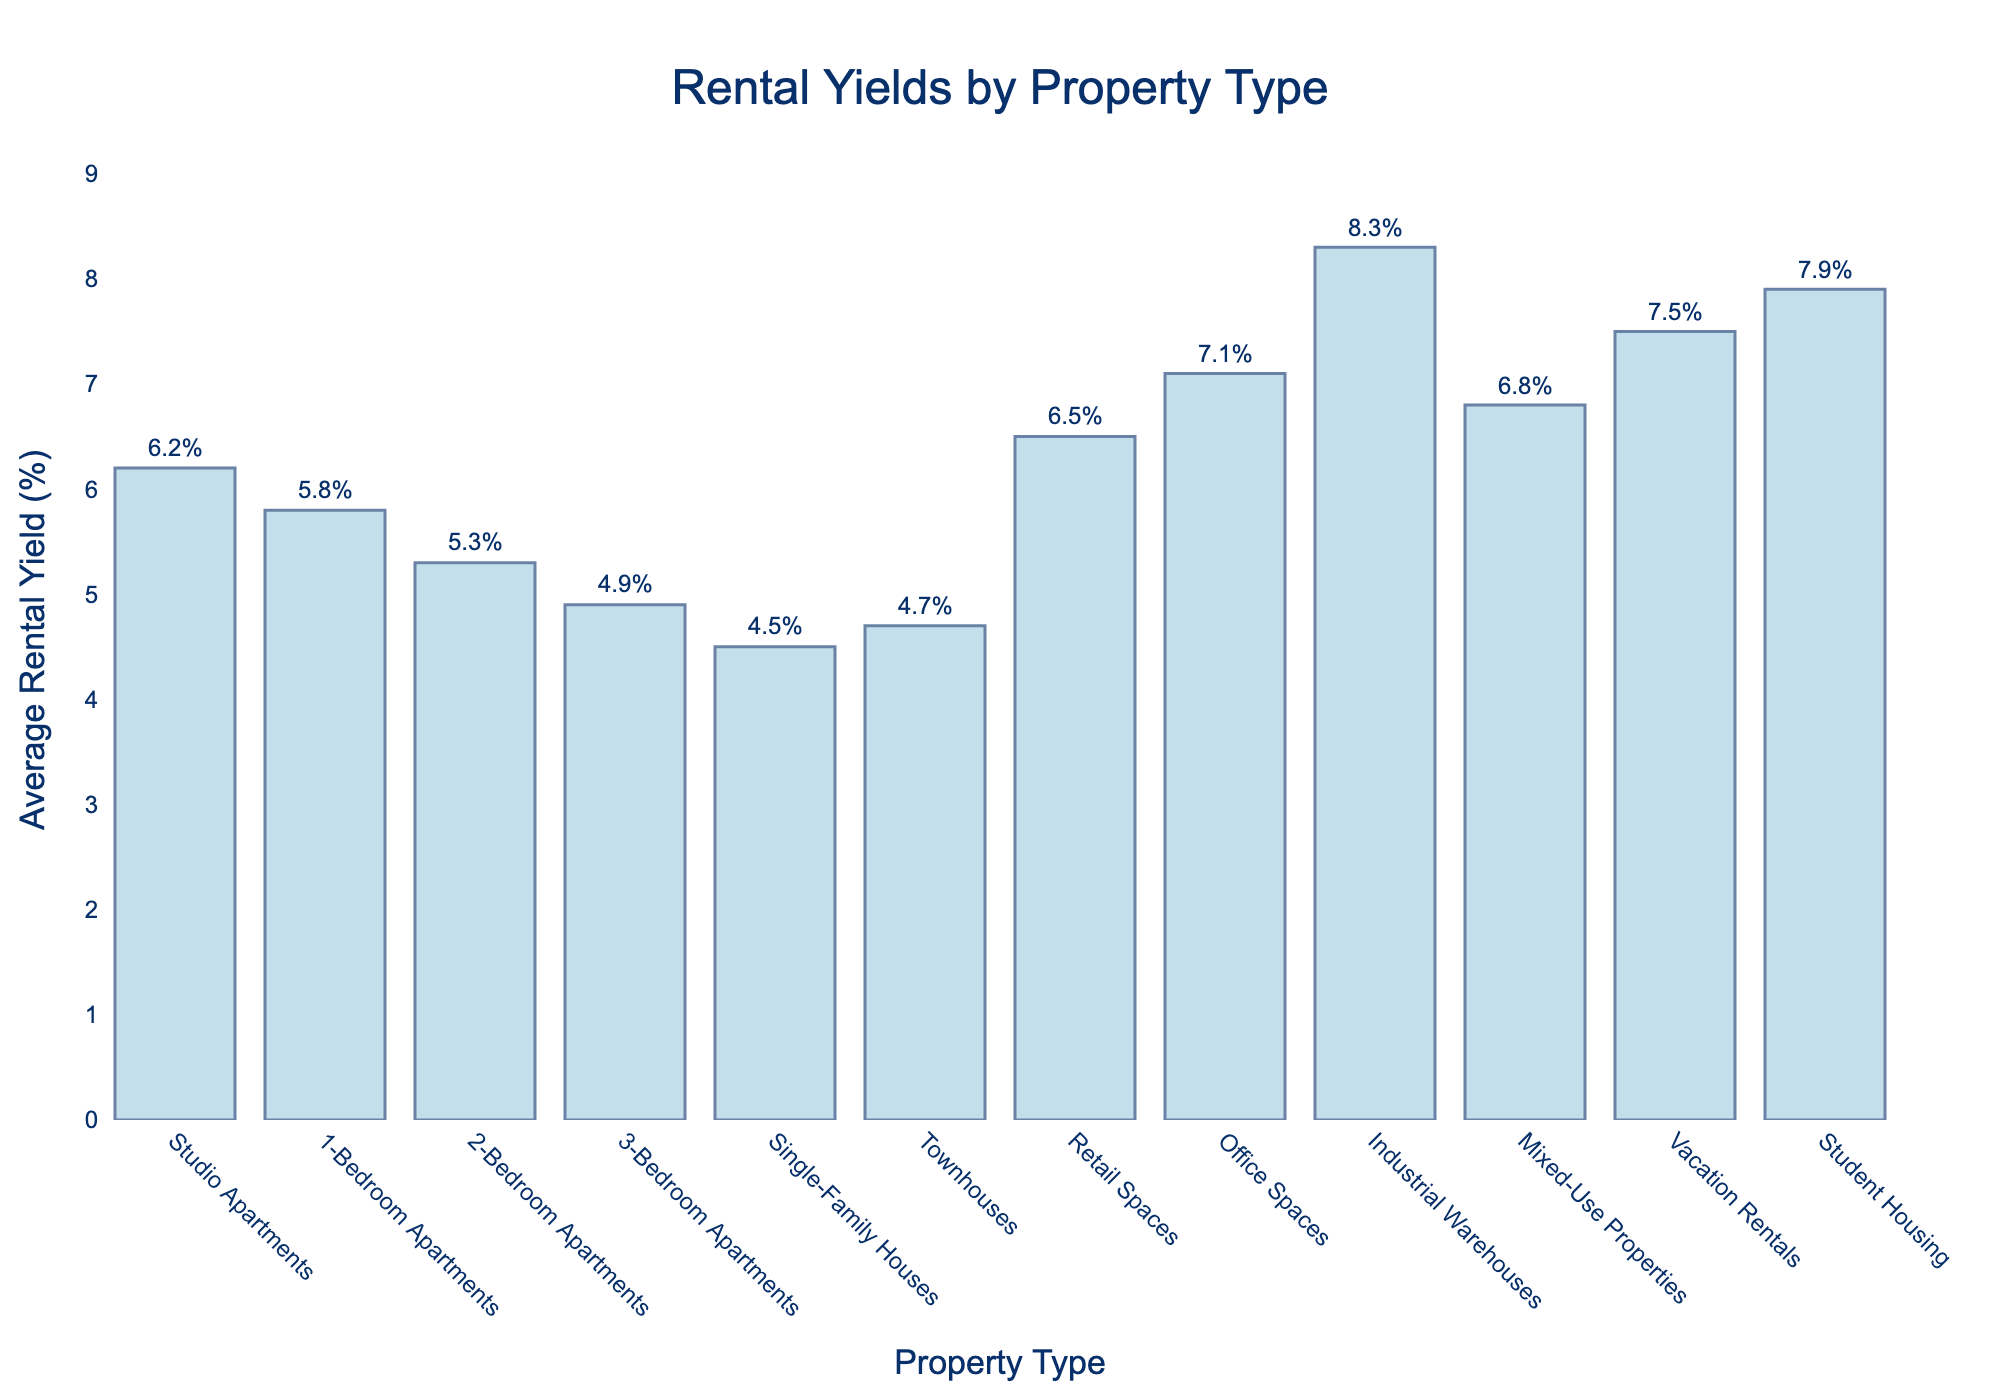Which property type has the highest rental yield? Look at the bar with the greatest height. Office Spaces have the highest rental yield at 8.3%.
Answer: Office Spaces What is the difference in rental yields between Studio Apartments and Single-Family Houses? The rental yield for Studio Apartments is 6.2%, and for Single-Family Houses, it is 4.5%. The difference is 6.2% - 4.5% = 1.7%.
Answer: 1.7% Are retail spaces more or less profitable than mixed-use properties in terms of rental yield? The rental yield for Retail Spaces is 6.5%, while for Mixed-Use Properties, it is 6.8%. Retail Spaces have a lower rental yield.
Answer: Less Which has a higher rental yield, Vacation Rentals or Student Housing? Compare the heights of the bars for Vacation Rentals and Student Housing. Vacation Rentals yield 7.5%, while Student Housing yields 7.9%. Student Housing has a higher yield.
Answer: Student Housing What is the average rental yield of 1-Bedroom Apartments, 2-Bedroom Apartments, and 3-Bedroom Apartments? Add the rental yields of these three property types: 5.8% + 5.3% + 4.9% = 16%. Divide by the number of property types: 16% / 3 = 5.33%.
Answer: 5.33% Which property type yields slightly less than Retail Spaces? Check the property types with yields close to 6.5%. Mixed-Use Properties yield 6.8%, slightly more, so Retail Spaces yield slightly less.
Answer: Retail Spaces What is the combined rental yield of Studio Apartments, Vacation Rentals, and Student Housing? Add the rental yields of these three property types: 6.2% + 7.5% + 7.9% = 21.6%.
Answer: 21.6% Between Industrial Warehouses and Townhouses, which has the lower rental yield and by how much? Compare the heights of the bars for Industrial Warehouses (8.3%) and Townhouses (4.7%). The difference is 8.3% - 4.7% = 3.6%, with Townhouses having the lower yield.
Answer: Townhouses, 3.6% Which property types fall below the 5% rental yield mark? Identify bars that are below the 5% mark on the y-axis. Single-Family Houses at 4.5% and 3-Bedroom Apartments at 4.9% fall below 5%.
Answer: Single-Family Houses, 3-Bedroom Apartments What's the median rental yield among all property types? List all yields: 4.5%, 4.7%, 4.9%, 5.3%, 5.8%, 6.2%, 6.5%, 6.8%, 7.1%, 7.5%, 7.9%, 8.3%. The middle value in this ordered list (6th and 7th positions) are 6.2% and 6.5%. The median is (6.2% + 6.5%) / 2 = 6.35%.
Answer: 6.35% 